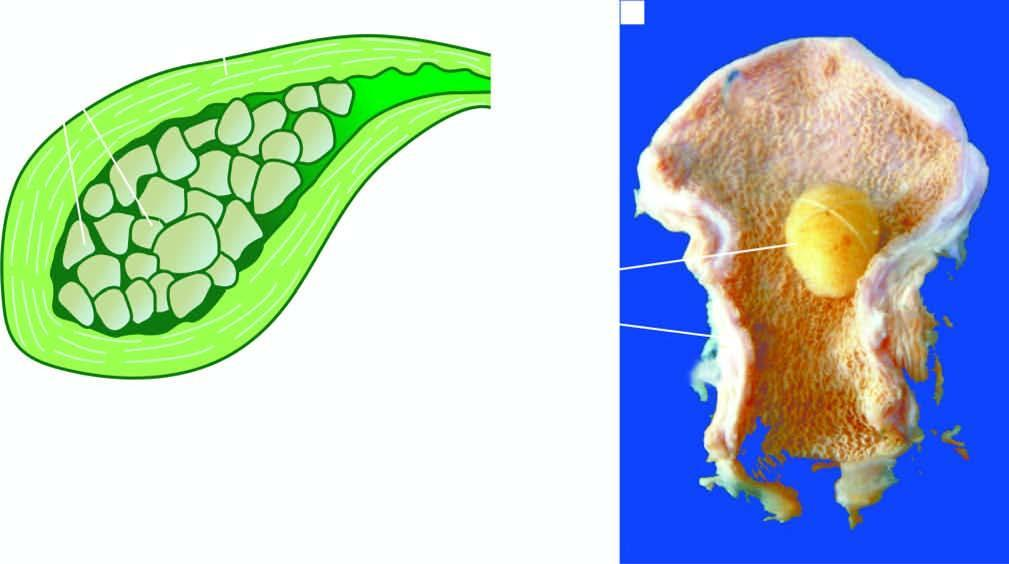s the viral envelope thickened?
Answer the question using a single word or phrase. No 